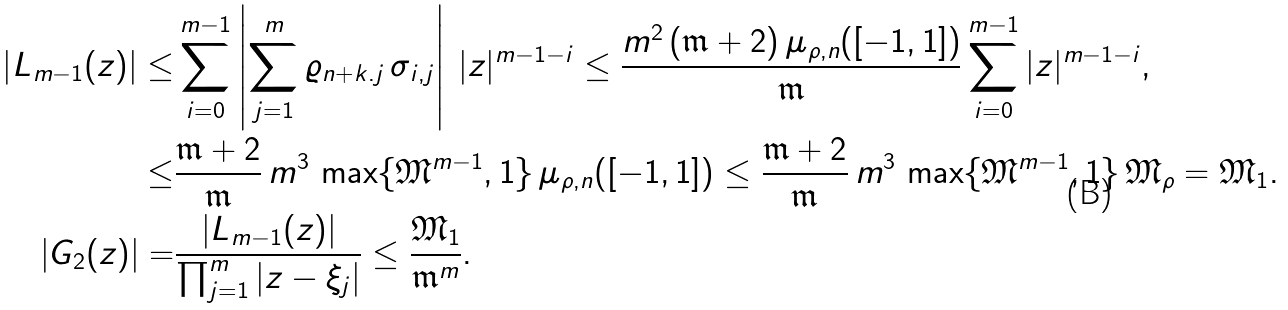<formula> <loc_0><loc_0><loc_500><loc_500>\left | L _ { m - 1 } ( z ) \right | \leq & \sum _ { i = 0 } ^ { m - 1 } \left | \sum _ { j = 1 } ^ { m } \varrho _ { n + k . j } \, \sigma _ { i , j } \right | \, | z | ^ { m - 1 - i } \leq \frac { m ^ { 2 } \, ( \mathfrak { m } + 2 ) \, \mu _ { \rho , n } ( [ - 1 , 1 ] ) } { \mathfrak { m } } \sum _ { i = 0 } ^ { m - 1 } | z | ^ { m - 1 - i } , \\ \leq & \frac { \mathfrak { m } + 2 } { \mathfrak { m } } \, m ^ { 3 } \, \max \{ \mathfrak { M } ^ { m - 1 } , 1 \} \, \mu _ { \rho , n } ( [ - 1 , 1 ] ) \leq \frac { \mathfrak { m } + 2 } { \mathfrak { m } } \, m ^ { 3 } \, \max \{ \mathfrak { M } ^ { m - 1 } , 1 \} \, \mathfrak { M } _ { \rho } = \mathfrak { M } _ { 1 } . \\ \left | G _ { 2 } ( z ) \right | = & \frac { \left | L _ { m - 1 } ( z ) \right | } { \prod _ { j = 1 } ^ { m } \left | z - \xi _ { j } \right | } \leq \frac { \mathfrak { M } _ { 1 } } { \mathfrak { m } ^ { m } } .</formula> 